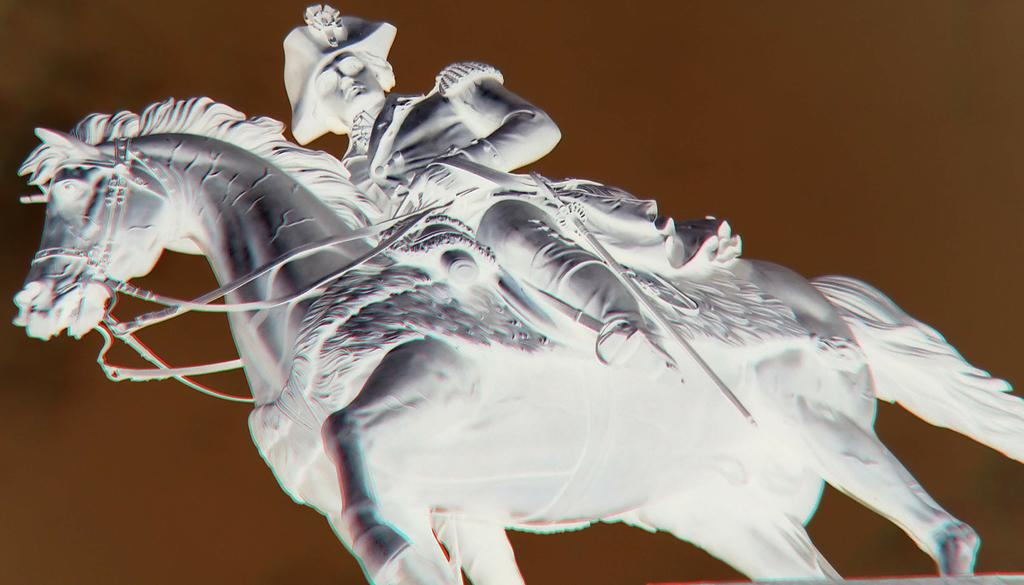What is the main subject of the image? There is a sculpture of a horse in the image. Are there any people present in the image? Yes, there is a person in the image. What is the color of the background in the image? The background color is light brown. Can you describe the setting of the image? The image may have been taken in a hall, based on the provided facts. How many thumbs does the horse sculpture have in the image? The horse sculpture does not have any thumbs, as it is a sculpture of a horse and not a human. 